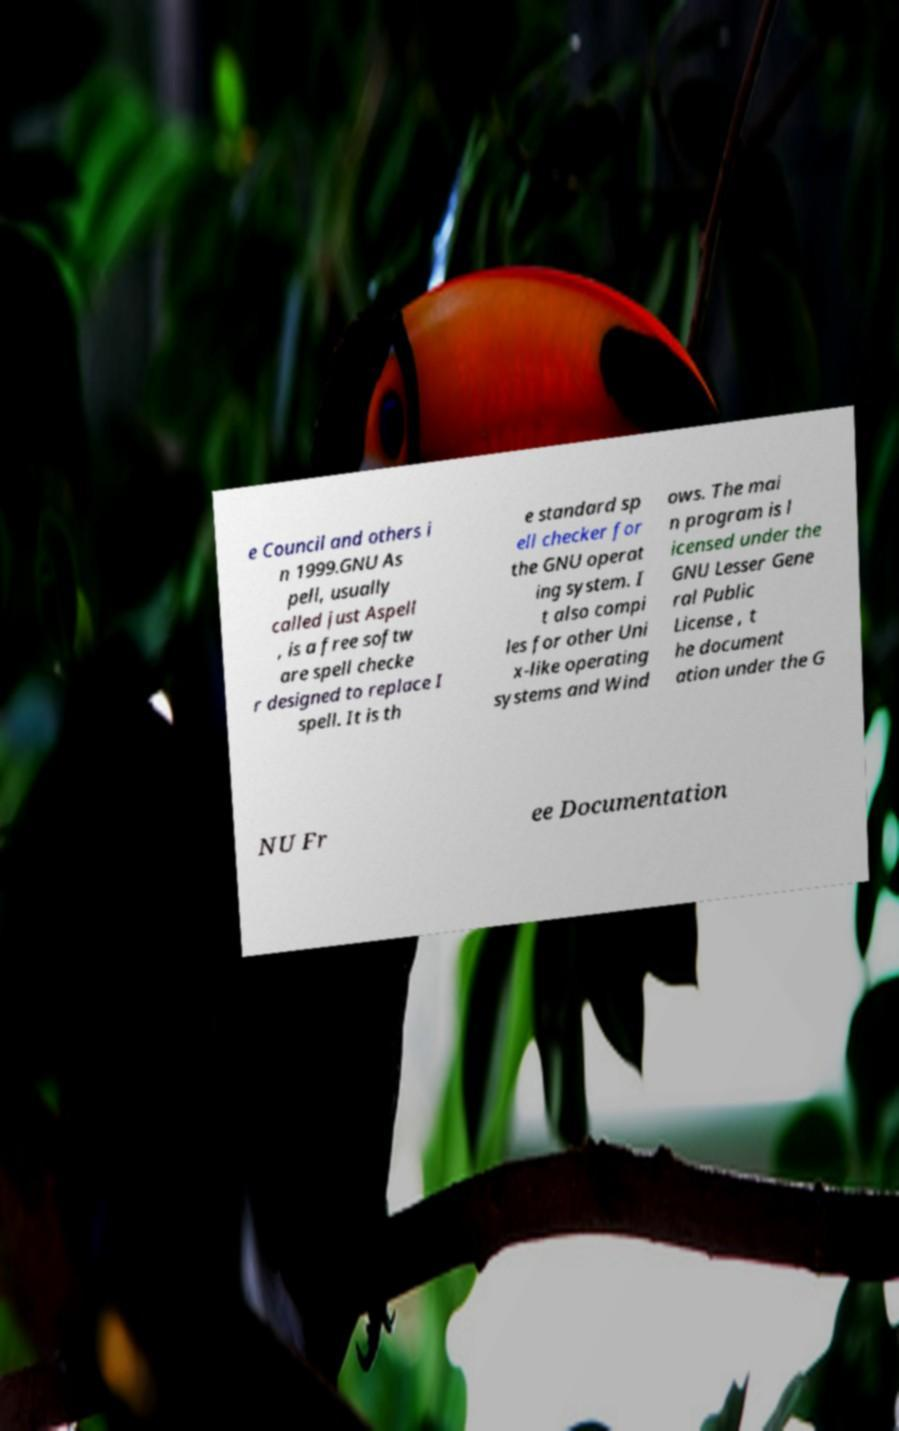Could you extract and type out the text from this image? e Council and others i n 1999.GNU As pell, usually called just Aspell , is a free softw are spell checke r designed to replace I spell. It is th e standard sp ell checker for the GNU operat ing system. I t also compi les for other Uni x-like operating systems and Wind ows. The mai n program is l icensed under the GNU Lesser Gene ral Public License , t he document ation under the G NU Fr ee Documentation 